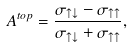Convert formula to latex. <formula><loc_0><loc_0><loc_500><loc_500>A ^ { t o p } = { \frac { \sigma _ { \uparrow \downarrow } - \sigma _ { \uparrow \uparrow } } { \sigma _ { \uparrow \downarrow } + \sigma _ { \uparrow \uparrow } } } ,</formula> 